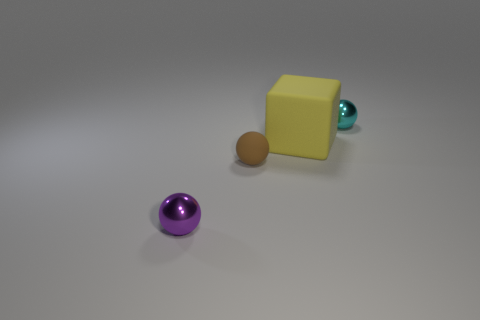Do the cyan shiny ball and the matte block have the same size?
Offer a terse response. No. Are there any big metallic balls that have the same color as the matte block?
Give a very brief answer. No. There is a metallic thing that is behind the big yellow matte block; does it have the same shape as the big thing?
Ensure brevity in your answer.  No. What number of blue shiny blocks are the same size as the cyan metallic sphere?
Ensure brevity in your answer.  0. There is a metallic thing behind the tiny brown rubber ball; what number of tiny cyan shiny things are behind it?
Ensure brevity in your answer.  0. Is the small brown object that is in front of the cyan object made of the same material as the purple object?
Make the answer very short. No. Is the material of the tiny object right of the cube the same as the object in front of the brown sphere?
Give a very brief answer. Yes. Are there more tiny spheres that are behind the cube than blocks?
Your answer should be compact. No. What color is the tiny shiny object in front of the tiny shiny sphere on the right side of the purple object?
Keep it short and to the point. Purple. There is a brown matte thing that is the same size as the purple sphere; what shape is it?
Make the answer very short. Sphere. 